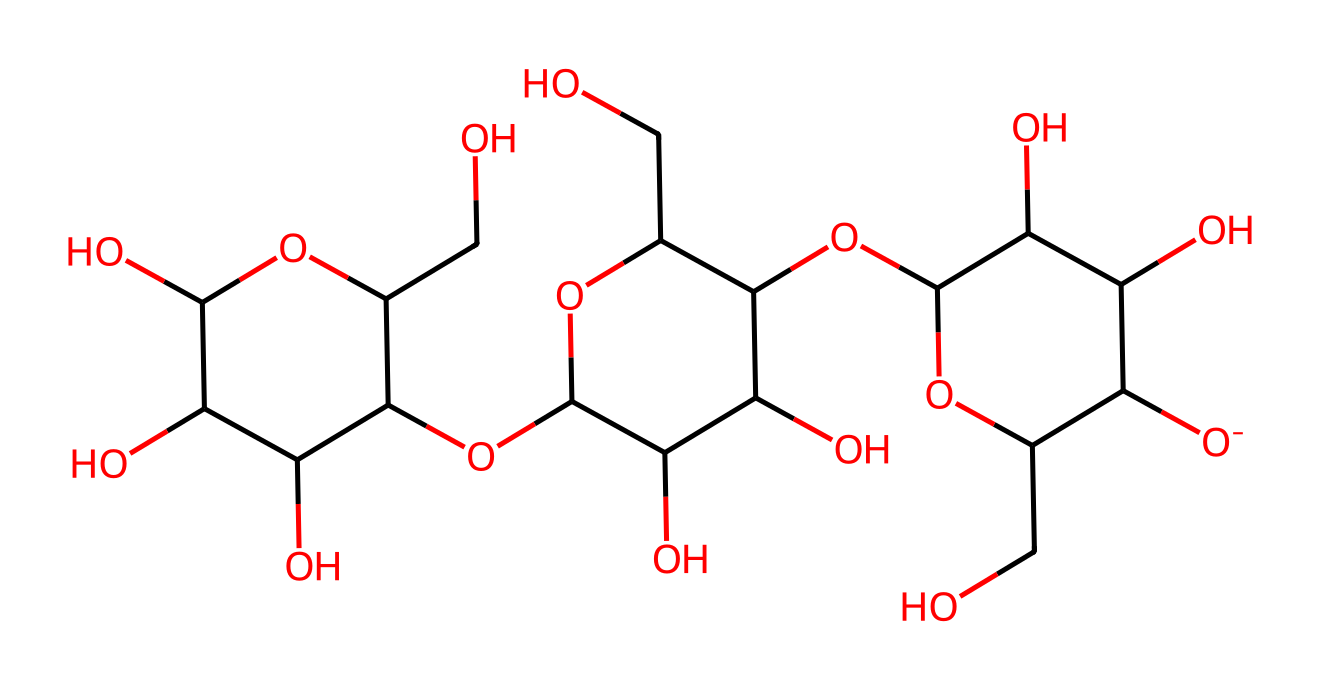What is the total number of carbon atoms in the structure? To find the number of carbon atoms, identify and count each carbon (C) atom in the SMILES representation. There are a total of 6 rings in the structure, implying multiple carbon atoms are linked. Counting these via the SMILES, there are 12 carbon atoms.
Answer: 12 How many oxygen atoms are present in the chemical structure? Count the oxygen (O) atoms shown in the SMILES representation. Each occurrence of 'O' corresponds to one oxygen atom. By going through the SMILES string, we find there are 8 oxygen atoms present in the structure.
Answer: 8 What is the molecular weight of this chemical? To determine the molecular weight, calculate the weight contributions of each atom type (C, H, O) in the chemical and sum them. Using the weights: C (12.01 g/mol), H (1.008 g/mol), and O (16.00 g/mol), we can find the total by multiplying the number of each atom by its respective weight. The final calculated molecular weight for this structure is approximately 342 g/mol.
Answer: 342 Is cellulose considered a non-electrolyte? Non-electrolytes are substances that do not dissociate into ions in solution. Cellulose, being a carbohydrate that is hydrophilic and does not dissociate into ions, is classified as a non-electrolyte.
Answer: Yes Which parts of the cellulose structure contribute to its solubility in water? The structure of cellulose contains multiple hydroxyl (–OH) groups, which are polar. This polarity enhances hydrogen bonding with water, leading to its solubility. The arrangement and presence of these –OH groups contribute significantly to cellulose's solubility in water.
Answer: Hydroxyl groups What distinguishes cellulose from other polysaccharides? Cellulose is distinguished from other polysaccharides by its beta(1→4) glycosidic bonds, totaling a linear chain that forms microfibrils. Unlike starch, which is branched, cellulose maintains a straight-chain structure, influencing its properties and interaction with water.
Answer: Beta(1→4) bonds 